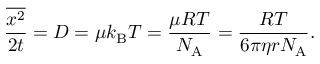<formula> <loc_0><loc_0><loc_500><loc_500>{ \frac { \overline { { x ^ { 2 } } } } { 2 t } } = D = \mu k _ { B } T = { \frac { \mu R T } { N _ { A } } } = { \frac { R T } { 6 \pi \eta r N _ { A } } } .</formula> 